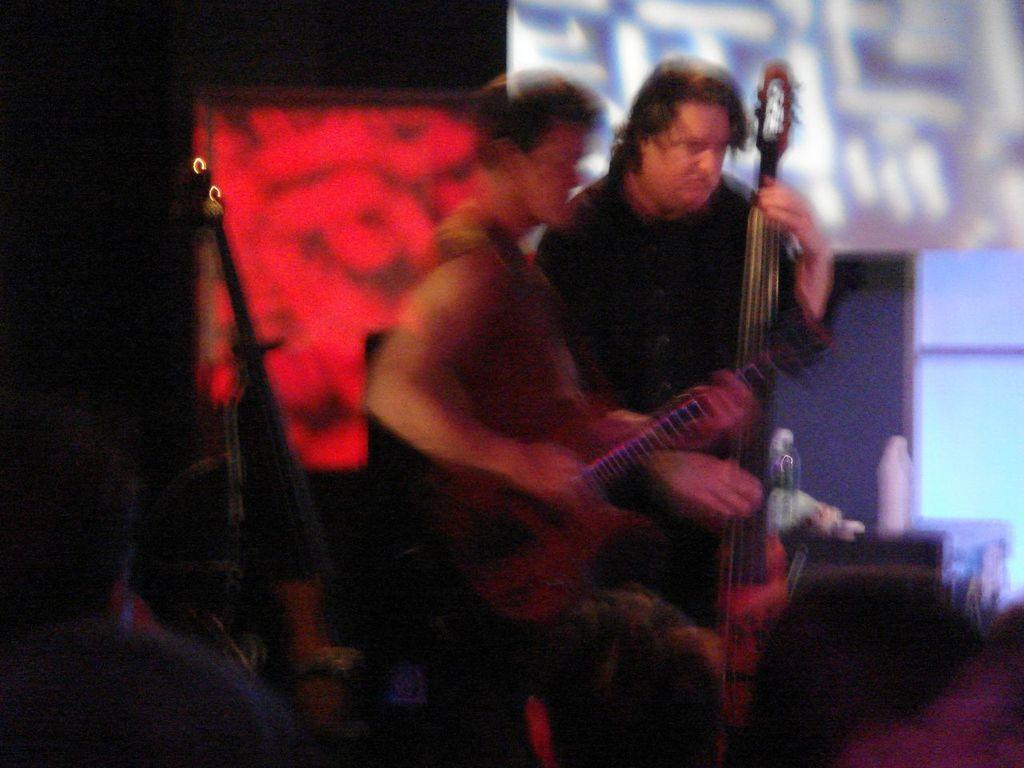What are the persons in the image doing? The persons in the image are playing musical instruments. Can you describe anything else visible in the image? Yes, there are bottles visible in the distance. What type of mint can be seen growing near the persons playing musical instruments? There is no mint visible in the image; only the persons playing musical instruments and the bottles in the distance are present. 